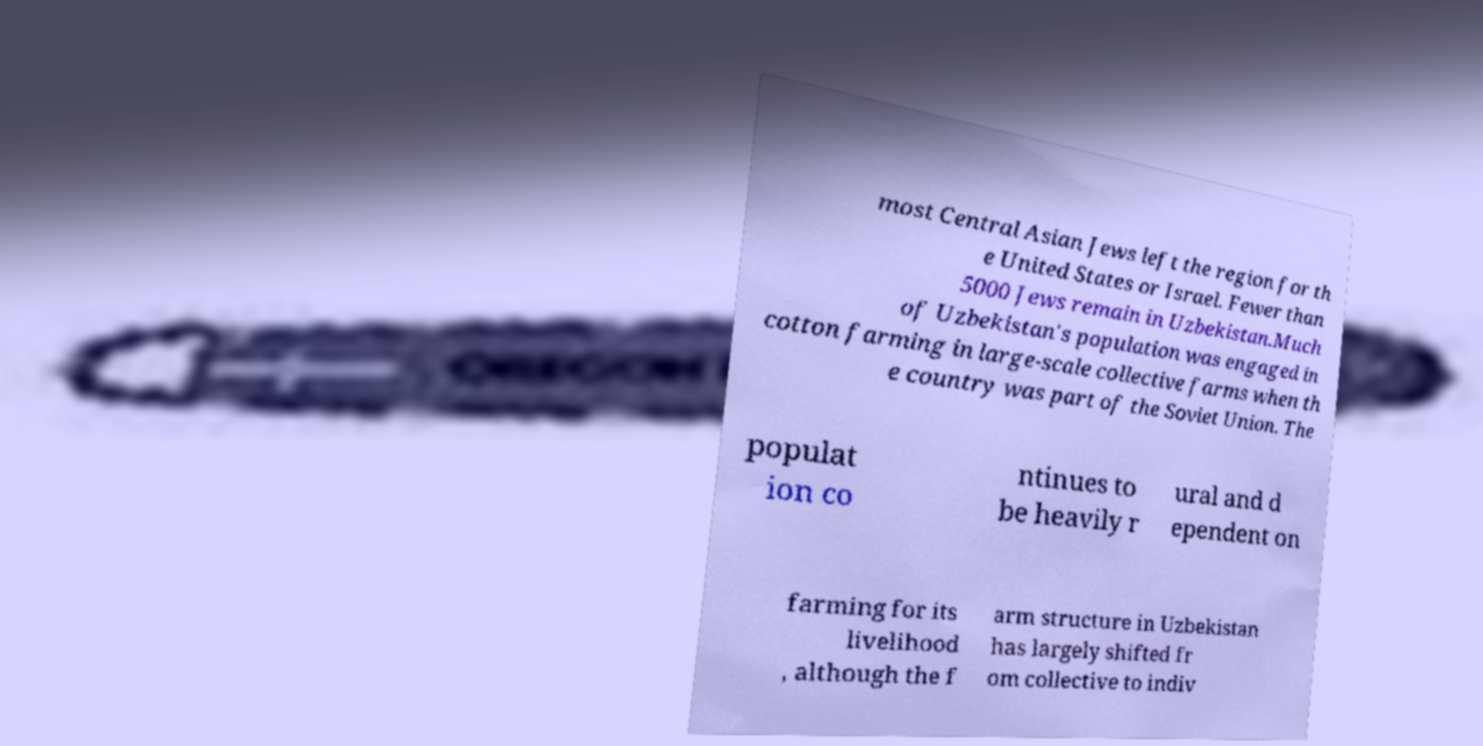What messages or text are displayed in this image? I need them in a readable, typed format. most Central Asian Jews left the region for th e United States or Israel. Fewer than 5000 Jews remain in Uzbekistan.Much of Uzbekistan's population was engaged in cotton farming in large-scale collective farms when th e country was part of the Soviet Union. The populat ion co ntinues to be heavily r ural and d ependent on farming for its livelihood , although the f arm structure in Uzbekistan has largely shifted fr om collective to indiv 